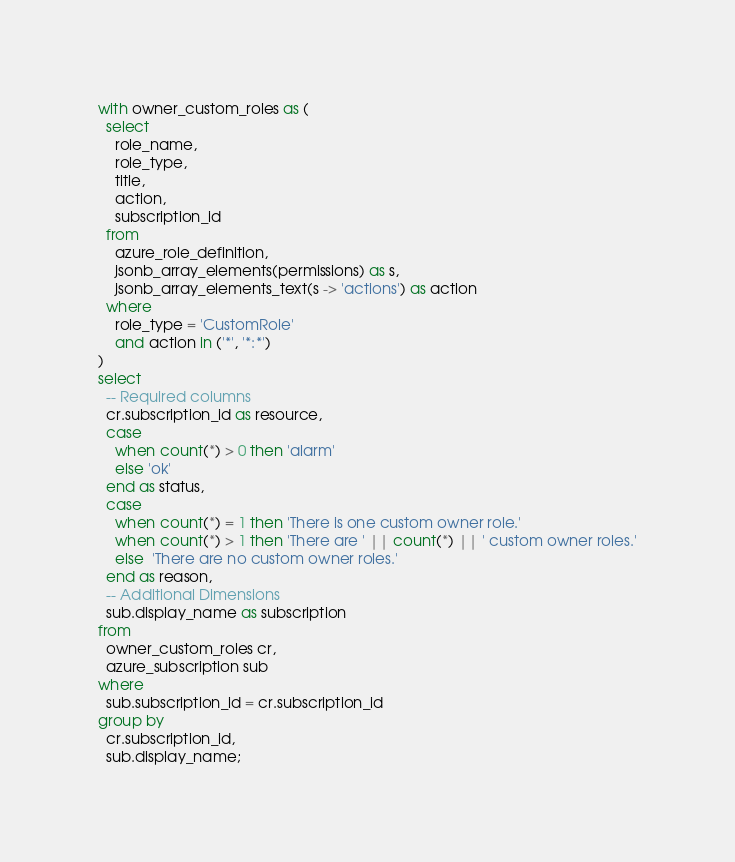<code> <loc_0><loc_0><loc_500><loc_500><_SQL_>with owner_custom_roles as (
  select
    role_name,
    role_type,
    title,
    action,
    subscription_id
  from
    azure_role_definition,
    jsonb_array_elements(permissions) as s,
    jsonb_array_elements_text(s -> 'actions') as action
  where
    role_type = 'CustomRole'
    and action in ('*', '*:*')
)
select
  -- Required columns
  cr.subscription_id as resource,
  case
    when count(*) > 0 then 'alarm'
    else 'ok'
  end as status,
  case
    when count(*) = 1 then 'There is one custom owner role.'
    when count(*) > 1 then 'There are ' || count(*) || ' custom owner roles.'
    else  'There are no custom owner roles.'
  end as reason,
  -- Additional Dimensions
  sub.display_name as subscription
from
  owner_custom_roles cr,
  azure_subscription sub
where
  sub.subscription_id = cr.subscription_id
group by
  cr.subscription_id,
  sub.display_name;</code> 